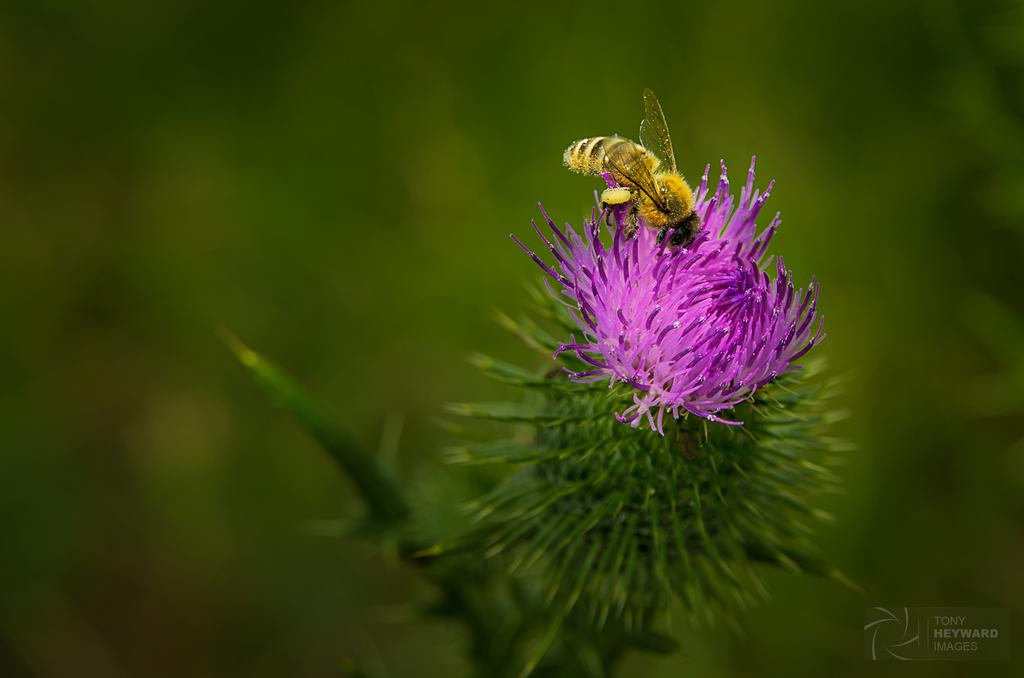What type of creature is present in the image? There is an insect in the image. Where is the insect located in the image? The insect is on a flower. How many ants are carrying the tray in the image? There are no ants or trays present in the image. What does the insect's mom look like in the image? There is no reference to the insect's mom in the image. 